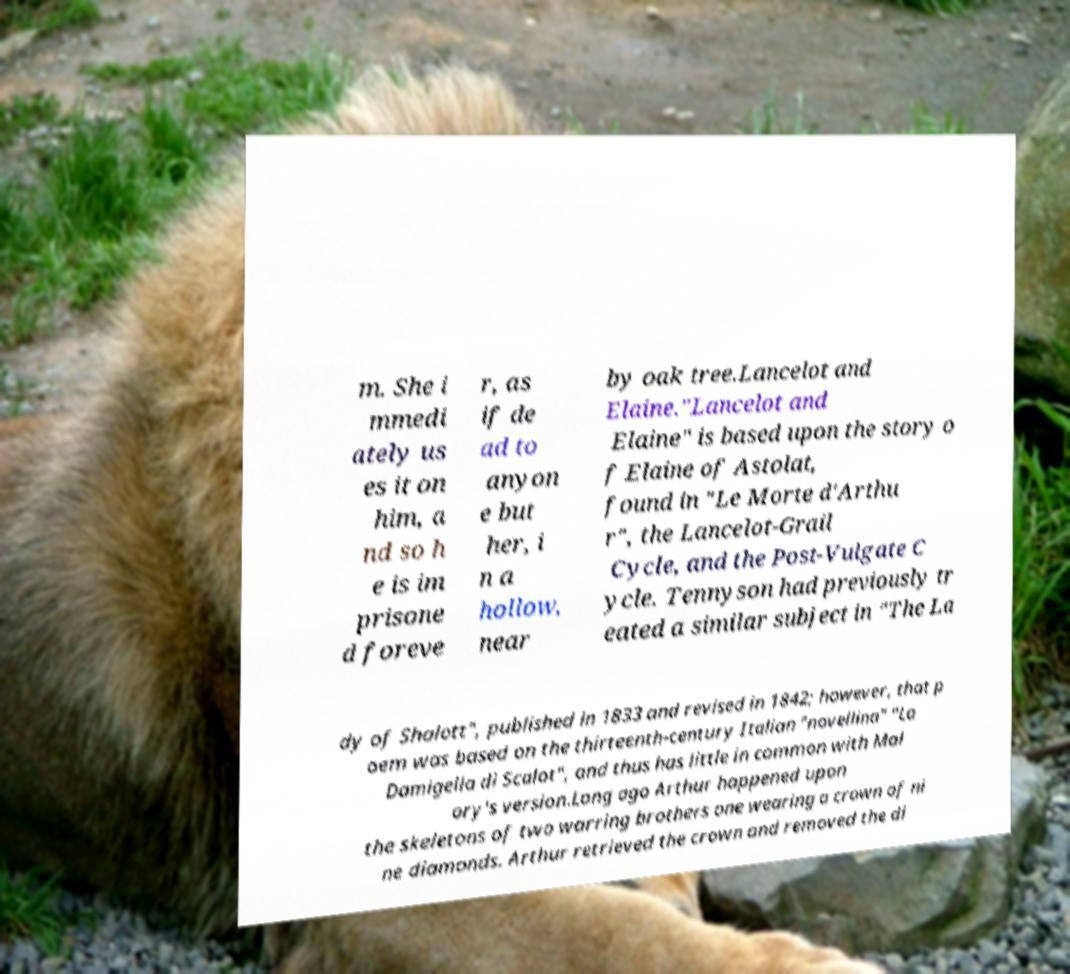Please read and relay the text visible in this image. What does it say? m. She i mmedi ately us es it on him, a nd so h e is im prisone d foreve r, as if de ad to anyon e but her, i n a hollow, near by oak tree.Lancelot and Elaine."Lancelot and Elaine" is based upon the story o f Elaine of Astolat, found in "Le Morte d'Arthu r", the Lancelot-Grail Cycle, and the Post-Vulgate C ycle. Tennyson had previously tr eated a similar subject in "The La dy of Shalott", published in 1833 and revised in 1842; however, that p oem was based on the thirteenth-century Italian "novellina" "La Damigella di Scalot", and thus has little in common with Mal ory's version.Long ago Arthur happened upon the skeletons of two warring brothers one wearing a crown of ni ne diamonds. Arthur retrieved the crown and removed the di 